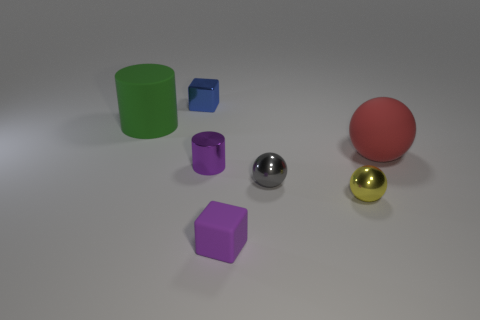Subtract all small shiny spheres. How many spheres are left? 1 Subtract 1 spheres. How many spheres are left? 2 Subtract all balls. How many objects are left? 4 Add 2 matte blocks. How many objects exist? 9 Add 3 small blue cubes. How many small blue cubes exist? 4 Subtract 0 green spheres. How many objects are left? 7 Subtract all tiny gray cubes. Subtract all big red rubber balls. How many objects are left? 6 Add 1 purple cubes. How many purple cubes are left? 2 